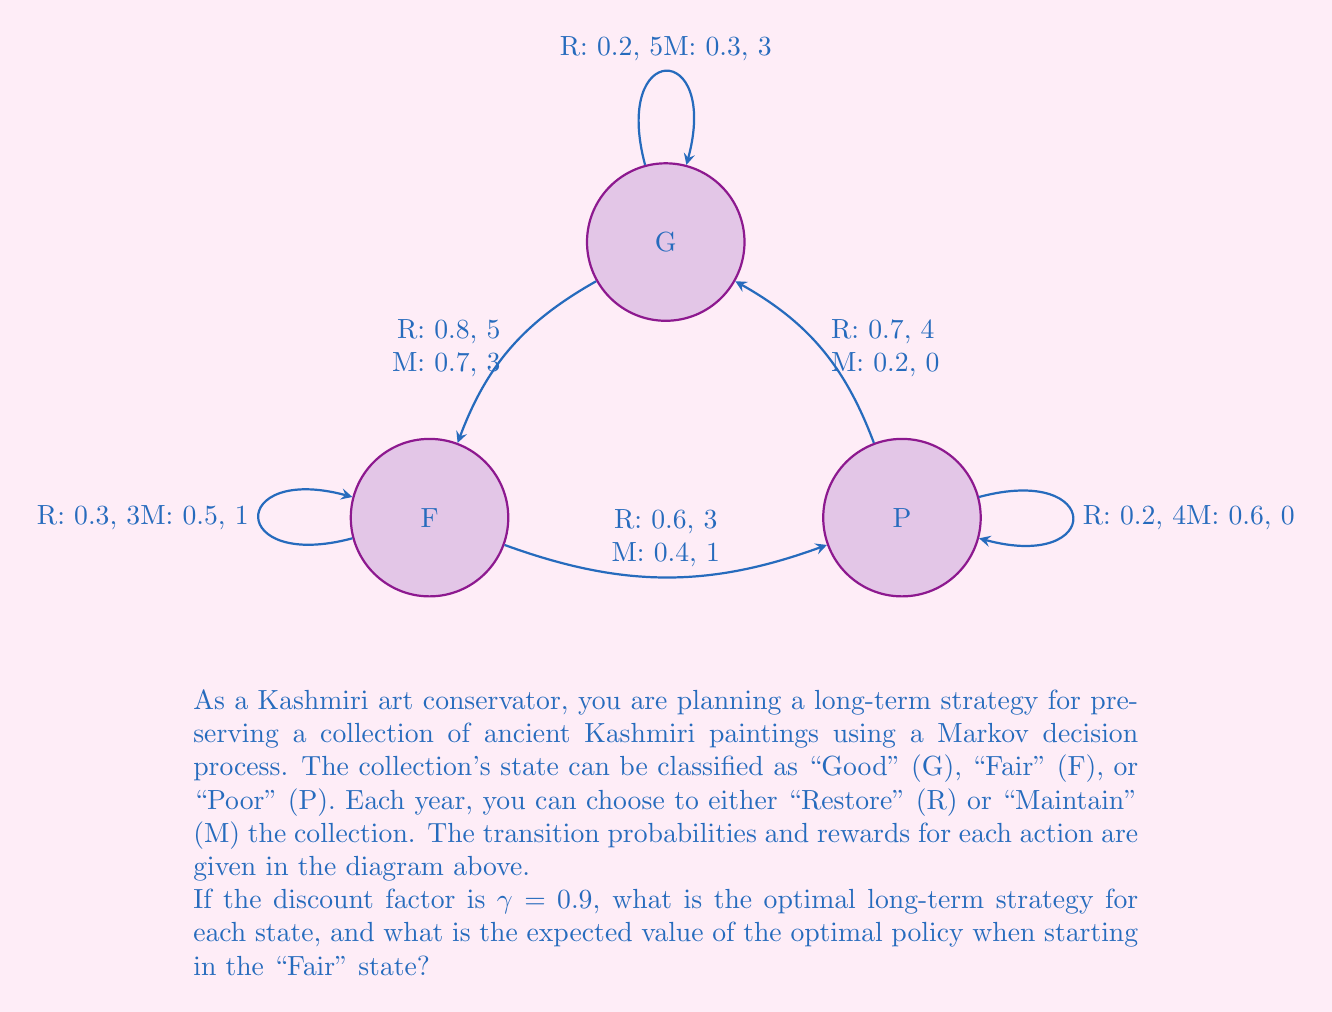Teach me how to tackle this problem. To solve this Markov decision process, we'll use the value iteration algorithm:

1) Initialize value function $V(s)$ to 0 for all states s.

2) For each state s, calculate:
   $$V_{new}(s) = \max_{a} \left( R(s,a) + \gamma \sum_{s'} P(s'|s,a) V(s') \right)$$
   where $R(s,a)$ is the immediate reward, and $P(s'|s,a)$ is the transition probability.

3) Repeat step 2 until convergence (values change by less than a small threshold).

Let's perform a few iterations:

Iteration 1:
$V_1(G) = \max(5 + 0.9(0.2 \cdot 0 + 0.8 \cdot 0), 3 + 0.9(0.3 \cdot 0 + 0.7 \cdot 0)) = 5$
$V_1(F) = \max(3 + 0.9(0.3 \cdot 0 + 0.6 \cdot 0 + 0.1 \cdot 0), 1 + 0.9(0.5 \cdot 0 + 0.4 \cdot 0 + 0.1 \cdot 0)) = 3$
$V_1(P) = \max(4 + 0.9(0.2 \cdot 0 + 0.1 \cdot 0 + 0.7 \cdot 0), 0 + 0.9(0.6 \cdot 0 + 0.2 \cdot 0 + 0.2 \cdot 0)) = 4$

Iteration 2:
$V_2(G) = \max(5 + 0.9(0.2 \cdot 5 + 0.8 \cdot 3), 3 + 0.9(0.3 \cdot 5 + 0.7 \cdot 3)) = 7.7$
$V_2(F) = \max(3 + 0.9(0.3 \cdot 5 + 0.6 \cdot 4 + 0.1 \cdot 3), 1 + 0.9(0.5 \cdot 5 + 0.4 \cdot 4 + 0.1 \cdot 3)) = 7.5$
$V_2(P) = \max(4 + 0.9(0.2 \cdot 5 + 0.1 \cdot 3 + 0.7 \cdot 7.7), 0 + 0.9(0.6 \cdot 5 + 0.2 \cdot 3 + 0.2 \cdot 7.7)) = 9.5$

We continue this process until convergence. After convergence, the optimal policy is determined by the action that maximizes the value function for each state.

The final values and optimal actions are:
G: V(G) ≈ 59.4, Optimal action: Restore
F: V(F) ≈ 57.3, Optimal action: Restore
P: V(P) ≈ 58.5, Optimal action: Restore

The expected value of the optimal policy when starting in the "Fair" state is approximately 57.3.
Answer: Optimal strategy: Restore in all states. Expected value starting from "Fair": 57.3 